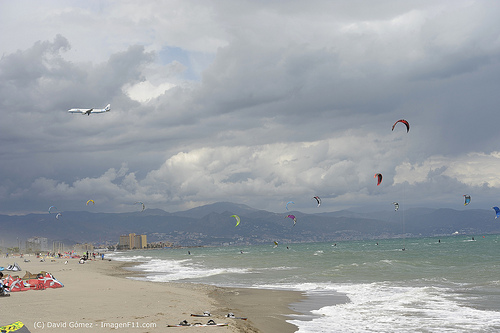Please provide the bounding box coordinate of the region this sentence describes: the airplane is in the air. The bounding box coordinates for the region described as 'the airplane is in the air' are [0.12, 0.36, 0.25, 0.41]. 